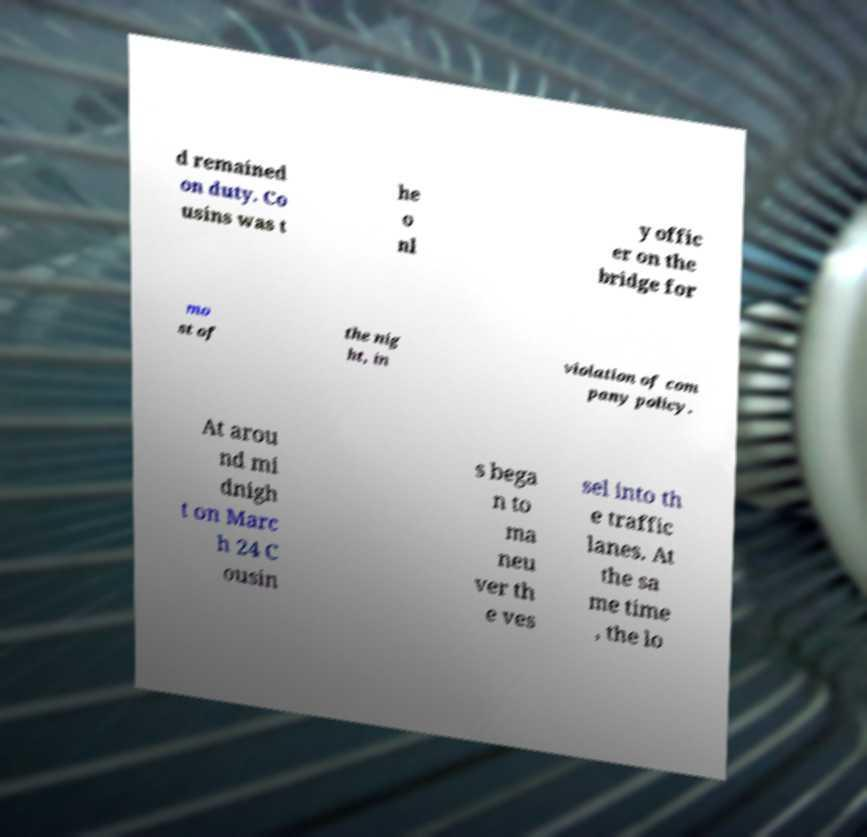Please identify and transcribe the text found in this image. d remained on duty. Co usins was t he o nl y offic er on the bridge for mo st of the nig ht, in violation of com pany policy. At arou nd mi dnigh t on Marc h 24 C ousin s bega n to ma neu ver th e ves sel into th e traffic lanes. At the sa me time , the lo 